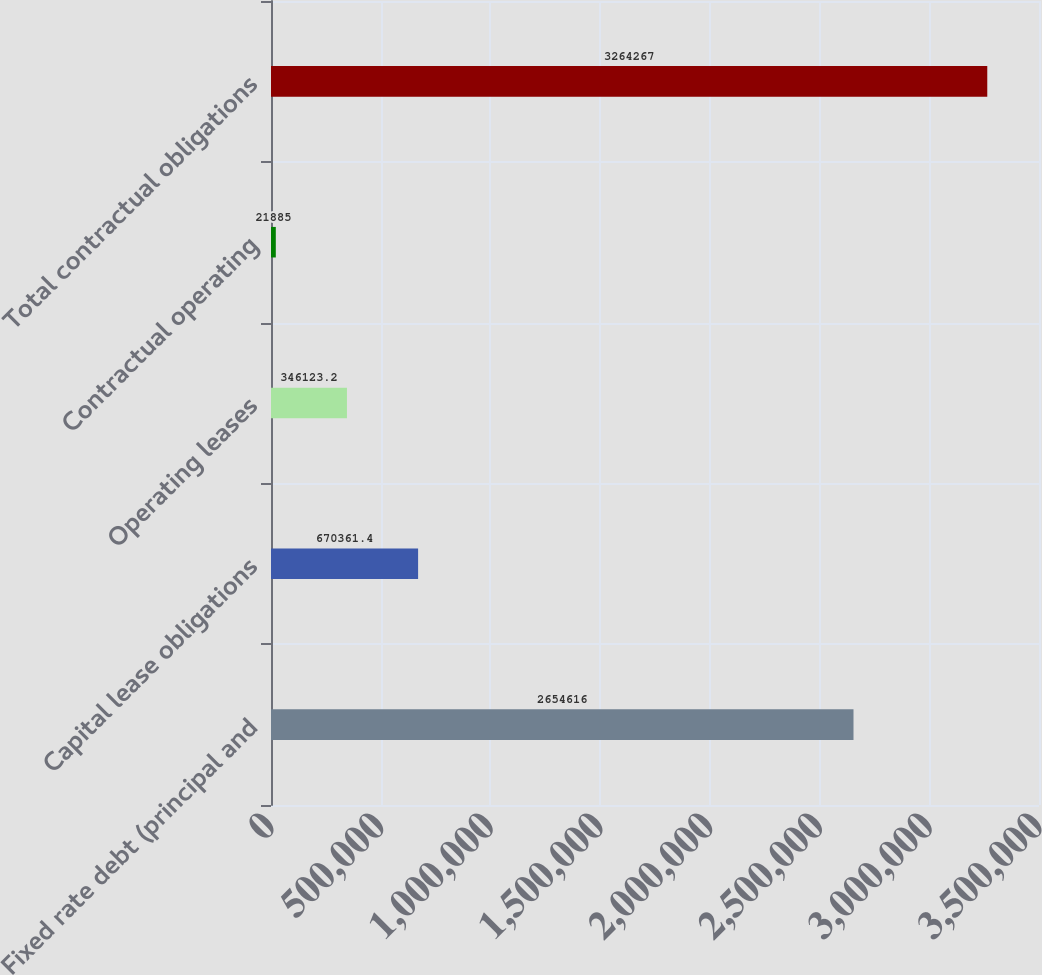Convert chart to OTSL. <chart><loc_0><loc_0><loc_500><loc_500><bar_chart><fcel>Fixed rate debt (principal and<fcel>Capital lease obligations<fcel>Operating leases<fcel>Contractual operating<fcel>Total contractual obligations<nl><fcel>2.65462e+06<fcel>670361<fcel>346123<fcel>21885<fcel>3.26427e+06<nl></chart> 